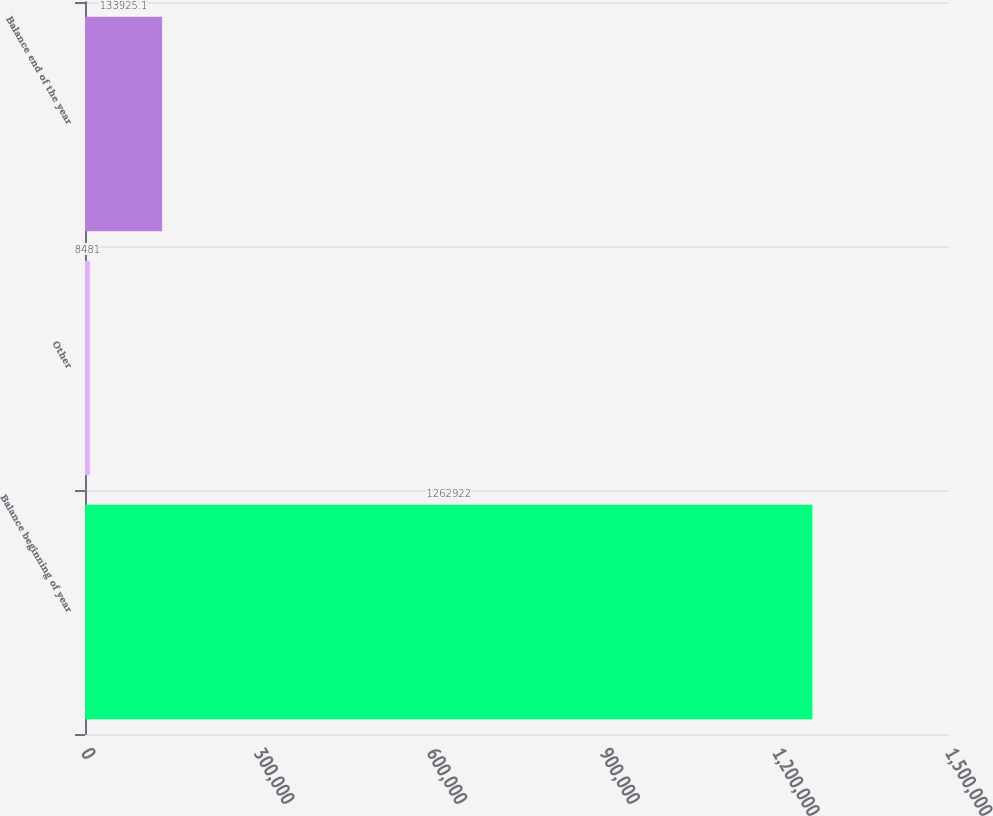Convert chart. <chart><loc_0><loc_0><loc_500><loc_500><bar_chart><fcel>Balance beginning of year<fcel>Other<fcel>Balance end of the year<nl><fcel>1.26292e+06<fcel>8481<fcel>133925<nl></chart> 